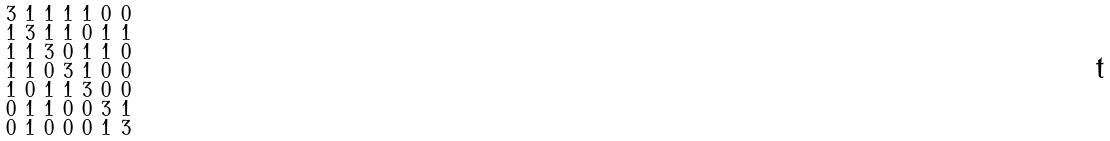<formula> <loc_0><loc_0><loc_500><loc_500>\begin{smallmatrix} 3 & 1 & 1 & 1 & 1 & 0 & 0 \\ 1 & 3 & 1 & 1 & 0 & 1 & 1 \\ 1 & 1 & 3 & 0 & 1 & 1 & 0 \\ 1 & 1 & 0 & 3 & 1 & 0 & 0 \\ 1 & 0 & 1 & 1 & 3 & 0 & 0 \\ 0 & 1 & 1 & 0 & 0 & 3 & 1 \\ 0 & 1 & 0 & 0 & 0 & 1 & 3 \end{smallmatrix}</formula> 